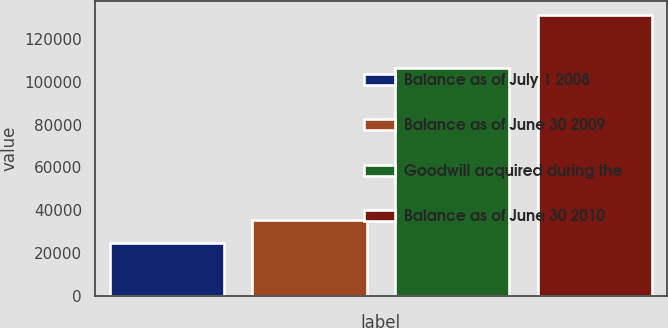<chart> <loc_0><loc_0><loc_500><loc_500><bar_chart><fcel>Balance as of July 1 2008<fcel>Balance as of June 30 2009<fcel>Goodwill acquired during the<fcel>Balance as of June 30 2010<nl><fcel>24798<fcel>35436.7<fcel>106387<fcel>131185<nl></chart> 